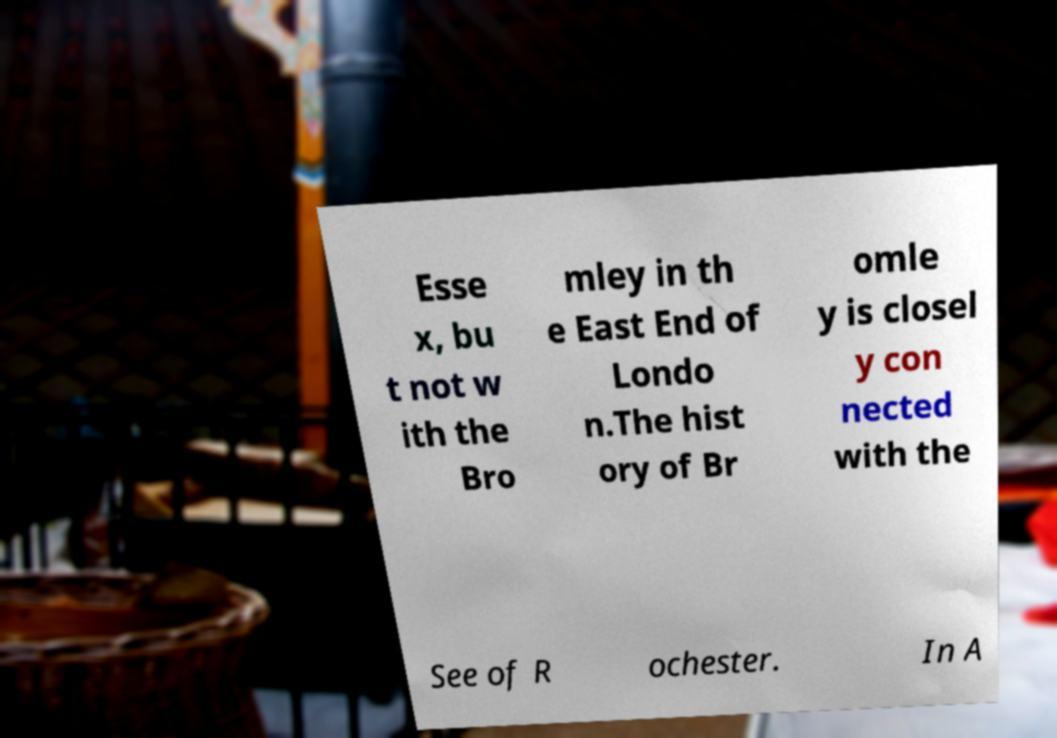Could you extract and type out the text from this image? Esse x, bu t not w ith the Bro mley in th e East End of Londo n.The hist ory of Br omle y is closel y con nected with the See of R ochester. In A 